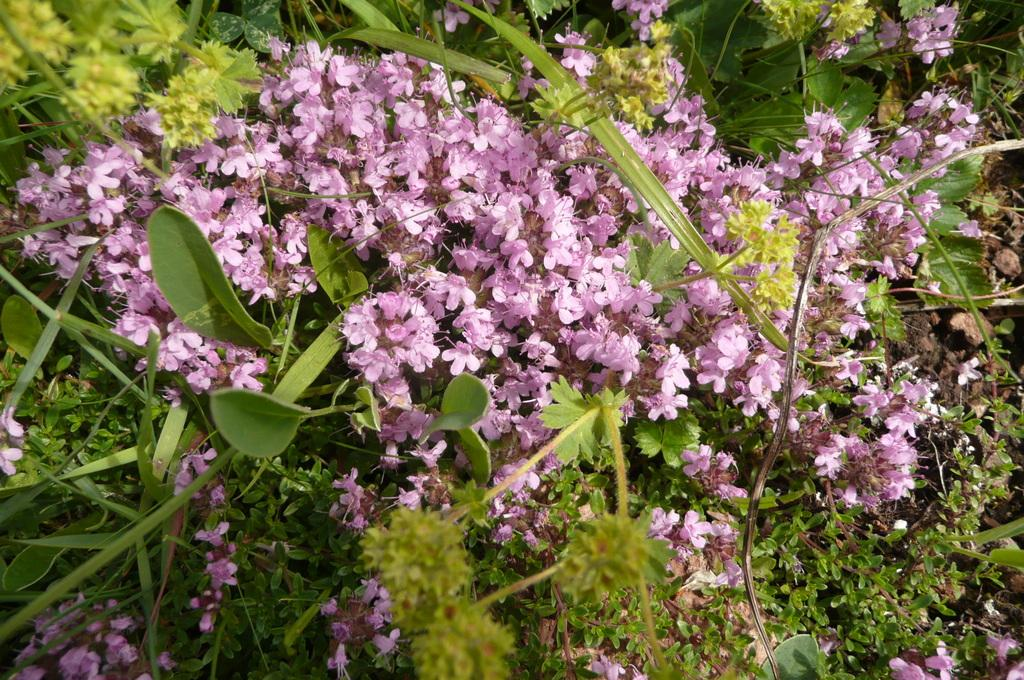What celestial bodies can be seen in the image? There are planets visible in the image. What type of flora is present in the image? There are pink flowers in the image. What type of writing can be seen on the test in the image? There is no test present in the image. What is the vase used for in the image? There is no vase present in the image. 